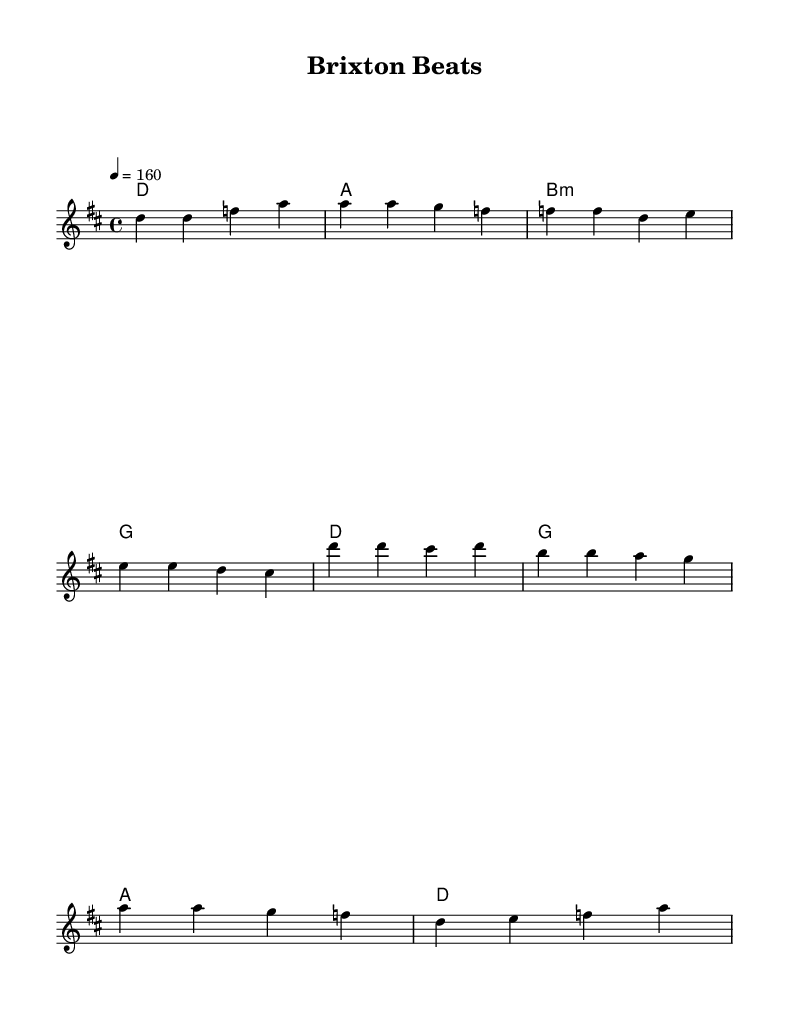What is the title of this music? The title is indicated at the top of the sheet music, which clearly states "Brixton Beats".
Answer: Brixton Beats What is the key signature of this music? The key signature is determined by the key indicated in the global section, which is D major, containing two sharps (F# and C#).
Answer: D major What is the time signature of this music? The time signature can be found in the global section where it shows "4/4", which means there are four beats in a measure.
Answer: 4/4 What is the tempo marking of this piece? The tempo marking can be found in the global section, where it states "4 = 160", indicating the beats per minute.
Answer: 160 How many measures are in the verse? The verse melody is structured over a total of four measures, as indicated by the division of the notes in the melodyVerse section.
Answer: four measures What themes are present in the lyrics? The lyrics reflect themes of immigration and pride, depicting an individual’s journey from Lagos to London, emphasizing connection to two cultures.
Answer: Immigration and pride What musical style does this piece exemplify? This piece exemplifies punk rock, indicated by the overall energy, rhythm, and lyrical focus on immigrant experiences which are characteristic of the genre.
Answer: Punk rock 